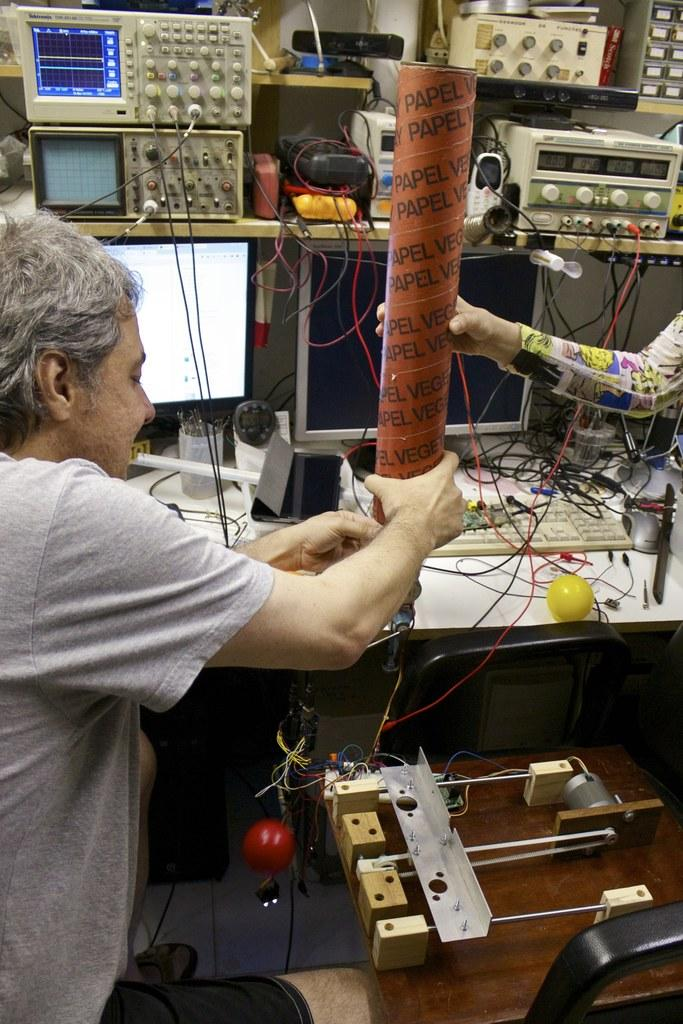What type of equipment can be seen in the image? There are machines in the image. What connects the machines in the image? Cables are present in the image. What is used to display information in the image? There is a computer display in the image. What is used to hold writing instruments in the image? There is a pen holder in the image. Who is present in the image? There are persons in the image. What type of stress-relief item can be seen in the image? There is a stress ball in the image. Where is the cobweb located in the image? There is no cobweb present in the image. How does the stress ball increase productivity in the image? The stress ball does not increase productivity in the image; it is a stress-relief item. 